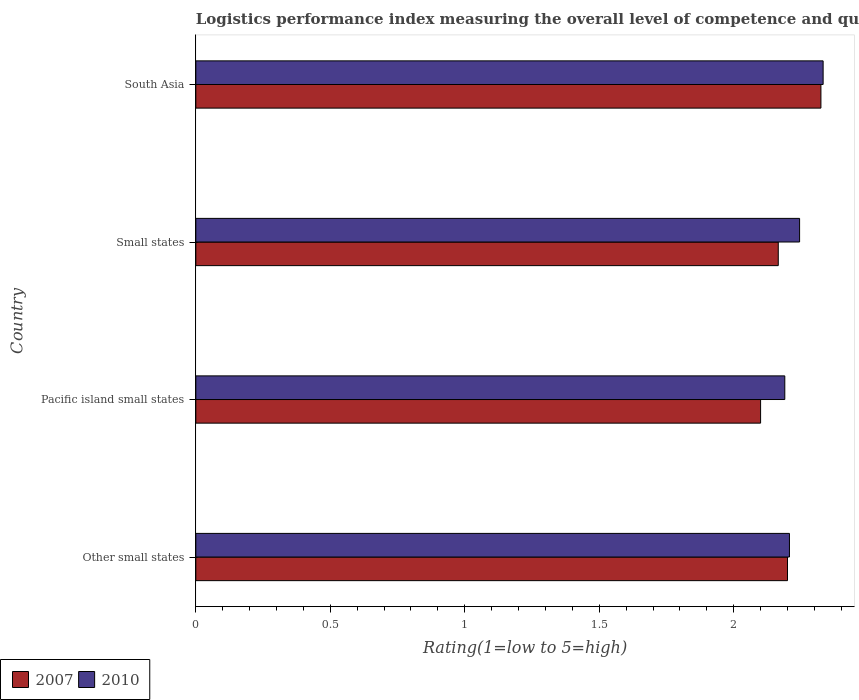Are the number of bars per tick equal to the number of legend labels?
Offer a very short reply. Yes. Are the number of bars on each tick of the Y-axis equal?
Give a very brief answer. Yes. How many bars are there on the 2nd tick from the top?
Give a very brief answer. 2. What is the label of the 1st group of bars from the top?
Your answer should be very brief. South Asia. What is the Logistic performance index in 2007 in Small states?
Provide a succinct answer. 2.17. Across all countries, what is the maximum Logistic performance index in 2010?
Your answer should be compact. 2.33. Across all countries, what is the minimum Logistic performance index in 2007?
Provide a short and direct response. 2.1. In which country was the Logistic performance index in 2007 maximum?
Provide a succinct answer. South Asia. In which country was the Logistic performance index in 2010 minimum?
Your answer should be compact. Pacific island small states. What is the total Logistic performance index in 2007 in the graph?
Ensure brevity in your answer.  8.79. What is the difference between the Logistic performance index in 2010 in Other small states and that in Pacific island small states?
Your response must be concise. 0.02. What is the difference between the Logistic performance index in 2010 in Small states and the Logistic performance index in 2007 in Other small states?
Your response must be concise. 0.04. What is the average Logistic performance index in 2007 per country?
Your response must be concise. 2.2. What is the difference between the Logistic performance index in 2010 and Logistic performance index in 2007 in Small states?
Give a very brief answer. 0.08. What is the ratio of the Logistic performance index in 2010 in Other small states to that in Pacific island small states?
Your answer should be very brief. 1.01. Is the Logistic performance index in 2010 in Pacific island small states less than that in Small states?
Provide a short and direct response. Yes. Is the difference between the Logistic performance index in 2010 in Pacific island small states and Small states greater than the difference between the Logistic performance index in 2007 in Pacific island small states and Small states?
Offer a terse response. Yes. What is the difference between the highest and the second highest Logistic performance index in 2010?
Offer a very short reply. 0.09. What is the difference between the highest and the lowest Logistic performance index in 2010?
Give a very brief answer. 0.14. In how many countries, is the Logistic performance index in 2007 greater than the average Logistic performance index in 2007 taken over all countries?
Offer a very short reply. 2. Is the sum of the Logistic performance index in 2007 in Other small states and Small states greater than the maximum Logistic performance index in 2010 across all countries?
Offer a terse response. Yes. What does the 2nd bar from the bottom in South Asia represents?
Make the answer very short. 2010. How many bars are there?
Your response must be concise. 8. Are all the bars in the graph horizontal?
Your response must be concise. Yes. What is the difference between two consecutive major ticks on the X-axis?
Give a very brief answer. 0.5. Are the values on the major ticks of X-axis written in scientific E-notation?
Your response must be concise. No. Does the graph contain any zero values?
Provide a short and direct response. No. Does the graph contain grids?
Make the answer very short. No. Where does the legend appear in the graph?
Provide a succinct answer. Bottom left. What is the title of the graph?
Make the answer very short. Logistics performance index measuring the overall level of competence and quality of logistics services. What is the label or title of the X-axis?
Provide a succinct answer. Rating(1=low to 5=high). What is the label or title of the Y-axis?
Your answer should be compact. Country. What is the Rating(1=low to 5=high) in 2010 in Other small states?
Provide a succinct answer. 2.21. What is the Rating(1=low to 5=high) in 2007 in Pacific island small states?
Provide a short and direct response. 2.1. What is the Rating(1=low to 5=high) of 2010 in Pacific island small states?
Give a very brief answer. 2.19. What is the Rating(1=low to 5=high) of 2007 in Small states?
Your response must be concise. 2.17. What is the Rating(1=low to 5=high) of 2010 in Small states?
Your answer should be compact. 2.25. What is the Rating(1=low to 5=high) of 2007 in South Asia?
Provide a succinct answer. 2.32. What is the Rating(1=low to 5=high) in 2010 in South Asia?
Provide a short and direct response. 2.33. Across all countries, what is the maximum Rating(1=low to 5=high) of 2007?
Offer a very short reply. 2.32. Across all countries, what is the maximum Rating(1=low to 5=high) in 2010?
Your answer should be compact. 2.33. Across all countries, what is the minimum Rating(1=low to 5=high) of 2007?
Offer a very short reply. 2.1. Across all countries, what is the minimum Rating(1=low to 5=high) in 2010?
Your answer should be very brief. 2.19. What is the total Rating(1=low to 5=high) in 2007 in the graph?
Offer a very short reply. 8.79. What is the total Rating(1=low to 5=high) of 2010 in the graph?
Your response must be concise. 8.97. What is the difference between the Rating(1=low to 5=high) of 2010 in Other small states and that in Pacific island small states?
Provide a short and direct response. 0.02. What is the difference between the Rating(1=low to 5=high) in 2007 in Other small states and that in Small states?
Provide a short and direct response. 0.03. What is the difference between the Rating(1=low to 5=high) of 2010 in Other small states and that in Small states?
Provide a succinct answer. -0.04. What is the difference between the Rating(1=low to 5=high) in 2007 in Other small states and that in South Asia?
Your response must be concise. -0.12. What is the difference between the Rating(1=low to 5=high) of 2010 in Other small states and that in South Asia?
Keep it short and to the point. -0.13. What is the difference between the Rating(1=low to 5=high) of 2007 in Pacific island small states and that in Small states?
Offer a very short reply. -0.07. What is the difference between the Rating(1=low to 5=high) of 2010 in Pacific island small states and that in Small states?
Offer a very short reply. -0.06. What is the difference between the Rating(1=low to 5=high) of 2007 in Pacific island small states and that in South Asia?
Give a very brief answer. -0.22. What is the difference between the Rating(1=low to 5=high) of 2010 in Pacific island small states and that in South Asia?
Offer a terse response. -0.14. What is the difference between the Rating(1=low to 5=high) in 2007 in Small states and that in South Asia?
Your answer should be compact. -0.16. What is the difference between the Rating(1=low to 5=high) in 2010 in Small states and that in South Asia?
Keep it short and to the point. -0.09. What is the difference between the Rating(1=low to 5=high) in 2007 in Other small states and the Rating(1=low to 5=high) in 2010 in Pacific island small states?
Ensure brevity in your answer.  0.01. What is the difference between the Rating(1=low to 5=high) in 2007 in Other small states and the Rating(1=low to 5=high) in 2010 in Small states?
Provide a succinct answer. -0.04. What is the difference between the Rating(1=low to 5=high) in 2007 in Other small states and the Rating(1=low to 5=high) in 2010 in South Asia?
Your answer should be compact. -0.13. What is the difference between the Rating(1=low to 5=high) in 2007 in Pacific island small states and the Rating(1=low to 5=high) in 2010 in Small states?
Keep it short and to the point. -0.14. What is the difference between the Rating(1=low to 5=high) in 2007 in Pacific island small states and the Rating(1=low to 5=high) in 2010 in South Asia?
Offer a terse response. -0.23. What is the difference between the Rating(1=low to 5=high) of 2007 in Small states and the Rating(1=low to 5=high) of 2010 in South Asia?
Your answer should be very brief. -0.17. What is the average Rating(1=low to 5=high) of 2007 per country?
Give a very brief answer. 2.2. What is the average Rating(1=low to 5=high) in 2010 per country?
Keep it short and to the point. 2.24. What is the difference between the Rating(1=low to 5=high) of 2007 and Rating(1=low to 5=high) of 2010 in Other small states?
Offer a very short reply. -0.01. What is the difference between the Rating(1=low to 5=high) of 2007 and Rating(1=low to 5=high) of 2010 in Pacific island small states?
Ensure brevity in your answer.  -0.09. What is the difference between the Rating(1=low to 5=high) of 2007 and Rating(1=low to 5=high) of 2010 in Small states?
Your answer should be very brief. -0.08. What is the difference between the Rating(1=low to 5=high) of 2007 and Rating(1=low to 5=high) of 2010 in South Asia?
Make the answer very short. -0.01. What is the ratio of the Rating(1=low to 5=high) of 2007 in Other small states to that in Pacific island small states?
Keep it short and to the point. 1.05. What is the ratio of the Rating(1=low to 5=high) in 2010 in Other small states to that in Pacific island small states?
Your answer should be very brief. 1.01. What is the ratio of the Rating(1=low to 5=high) of 2007 in Other small states to that in Small states?
Keep it short and to the point. 1.02. What is the ratio of the Rating(1=low to 5=high) in 2010 in Other small states to that in Small states?
Offer a very short reply. 0.98. What is the ratio of the Rating(1=low to 5=high) of 2007 in Other small states to that in South Asia?
Keep it short and to the point. 0.95. What is the ratio of the Rating(1=low to 5=high) of 2010 in Other small states to that in South Asia?
Keep it short and to the point. 0.95. What is the ratio of the Rating(1=low to 5=high) of 2007 in Pacific island small states to that in Small states?
Provide a succinct answer. 0.97. What is the ratio of the Rating(1=low to 5=high) of 2010 in Pacific island small states to that in Small states?
Make the answer very short. 0.98. What is the ratio of the Rating(1=low to 5=high) in 2007 in Pacific island small states to that in South Asia?
Your answer should be very brief. 0.9. What is the ratio of the Rating(1=low to 5=high) in 2010 in Pacific island small states to that in South Asia?
Your response must be concise. 0.94. What is the ratio of the Rating(1=low to 5=high) in 2007 in Small states to that in South Asia?
Keep it short and to the point. 0.93. What is the ratio of the Rating(1=low to 5=high) of 2010 in Small states to that in South Asia?
Your response must be concise. 0.96. What is the difference between the highest and the second highest Rating(1=low to 5=high) of 2007?
Your answer should be compact. 0.12. What is the difference between the highest and the second highest Rating(1=low to 5=high) of 2010?
Offer a terse response. 0.09. What is the difference between the highest and the lowest Rating(1=low to 5=high) in 2007?
Your answer should be very brief. 0.22. What is the difference between the highest and the lowest Rating(1=low to 5=high) in 2010?
Offer a very short reply. 0.14. 